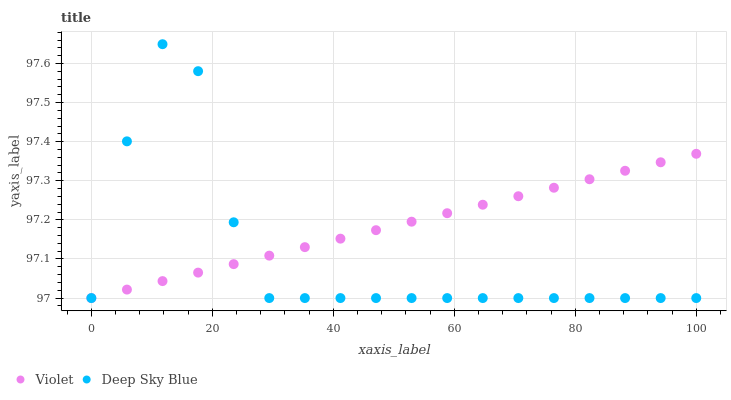Does Deep Sky Blue have the minimum area under the curve?
Answer yes or no. Yes. Does Violet have the maximum area under the curve?
Answer yes or no. Yes. Does Violet have the minimum area under the curve?
Answer yes or no. No. Is Violet the smoothest?
Answer yes or no. Yes. Is Deep Sky Blue the roughest?
Answer yes or no. Yes. Is Violet the roughest?
Answer yes or no. No. Does Deep Sky Blue have the lowest value?
Answer yes or no. Yes. Does Deep Sky Blue have the highest value?
Answer yes or no. Yes. Does Violet have the highest value?
Answer yes or no. No. Does Deep Sky Blue intersect Violet?
Answer yes or no. Yes. Is Deep Sky Blue less than Violet?
Answer yes or no. No. Is Deep Sky Blue greater than Violet?
Answer yes or no. No. 